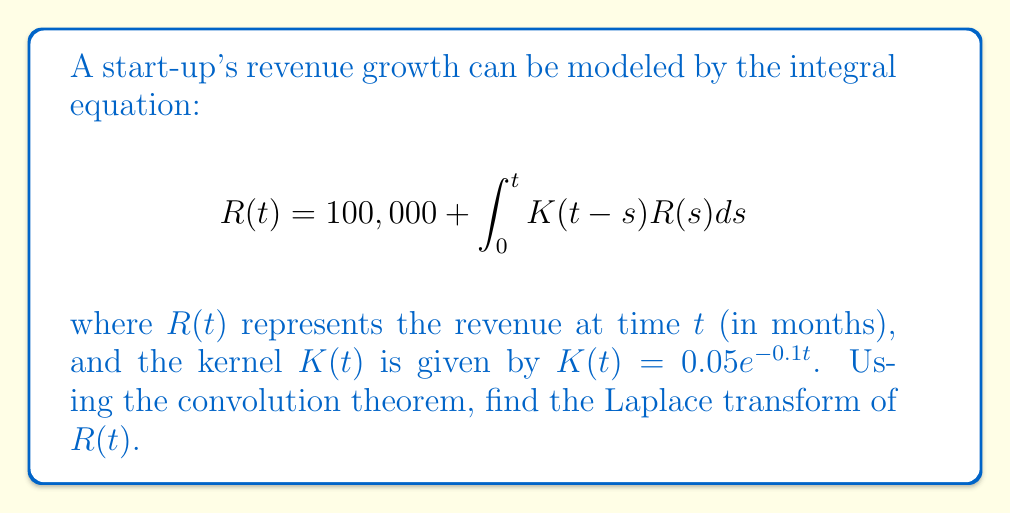Show me your answer to this math problem. 1) First, let's take the Laplace transform of both sides of the equation:
   $$\mathcal{L}\{R(t)\} = \mathcal{L}\{100,000\} + \mathcal{L}\{\int_0^t K(t-s)R(s)ds\}$$

2) Let $\mathcal{L}\{R(t)\} = \bar{R}(s)$. The Laplace transform of a constant is that constant divided by $s$:
   $$\bar{R}(s) = \frac{100,000}{s} + \mathcal{L}\{\int_0^t K(t-s)R(s)ds\}$$

3) The integral in the second term is a convolution. The convolution theorem states that the Laplace transform of a convolution of two functions is the product of their individual Laplace transforms:
   $$\bar{R}(s) = \frac{100,000}{s} + \mathcal{L}\{K(t)\} \cdot \mathcal{L}\{R(t)\}$$

4) We need to find $\mathcal{L}\{K(t)\}$:
   $$\mathcal{L}\{K(t)\} = \mathcal{L}\{0.05e^{-0.1t}\} = \frac{0.05}{s+0.1}$$

5) Substituting this back into our equation:
   $$\bar{R}(s) = \frac{100,000}{s} + \frac{0.05}{s+0.1} \cdot \bar{R}(s)$$

6) Now, let's solve for $\bar{R}(s)$:
   $$\bar{R}(s) - \frac{0.05}{s+0.1} \cdot \bar{R}(s) = \frac{100,000}{s}$$
   $$\bar{R}(s) \left(1 - \frac{0.05}{s+0.1}\right) = \frac{100,000}{s}$$
   $$\bar{R}(s) = \frac{100,000}{s} \cdot \frac{s+0.1}{s+0.05}$$

7) Simplifying:
   $$\bar{R}(s) = \frac{100,000(s+0.1)}{s(s+0.05)}$$
Answer: $$\bar{R}(s) = \frac{100,000(s+0.1)}{s(s+0.05)}$$ 